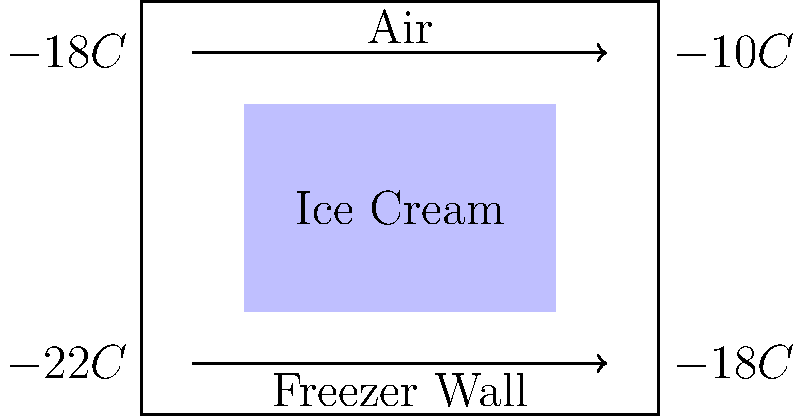Elsa, your daughter's favorite Frozen character, has magical ice powers. Imagine you're explaining to your daughter how a real freezer works using Elsa's ice palace as an analogy. If the temperature inside the freezer (Elsa's ice palace) is $-18°C$ and the temperature of the freezer's outer wall is $-10°C$, what is the rate of heat transfer through the freezer wall if its thermal conductivity is $0.05 \frac{W}{m \cdot K}$, the wall thickness is $5 \text{ cm}$, and the surface area is $2 \text{ m}^2$? Let's break this down step-by-step, as if explaining it to your daughter using the Frozen analogy:

1. Imagine Elsa's ice palace (our freezer) trying to keep the cold inside, just like Elsa's powers.

2. The temperature difference:
   Inside (Elsa's magic): $T_1 = -18°C$
   Outside (regular world): $T_2 = -10°C$
   Temperature difference: $\Delta T = T_2 - T_1 = -10°C - (-18°C) = 8°C$

3. The wall of Elsa's ice palace (freezer wall):
   Thickness: $L = 5 \text{ cm} = 0.05 \text{ m}$
   Area: $A = 2 \text{ m}^2$
   Thermal conductivity: $k = 0.05 \frac{W}{m \cdot K}$

4. We use Fourier's law of heat conduction, which is like measuring how fast Elsa's cold magic escapes:
   $Q = -k A \frac{\Delta T}{L}$

5. Plugging in our values:
   $Q = -0.05 \frac{W}{m \cdot K} \cdot 2 \text{ m}^2 \cdot \frac{8 K}{0.05 \text{ m}}$

6. Simplifying:
   $Q = -0.05 \cdot 2 \cdot \frac{8}{0.05} = -16 W$

7. The negative sign means heat is flowing out of the freezer (Elsa's cold magic is trying to escape).

Therefore, the rate of heat transfer is 16 watts, but we express it as a positive value when stating the magnitude.
Answer: 16 W 